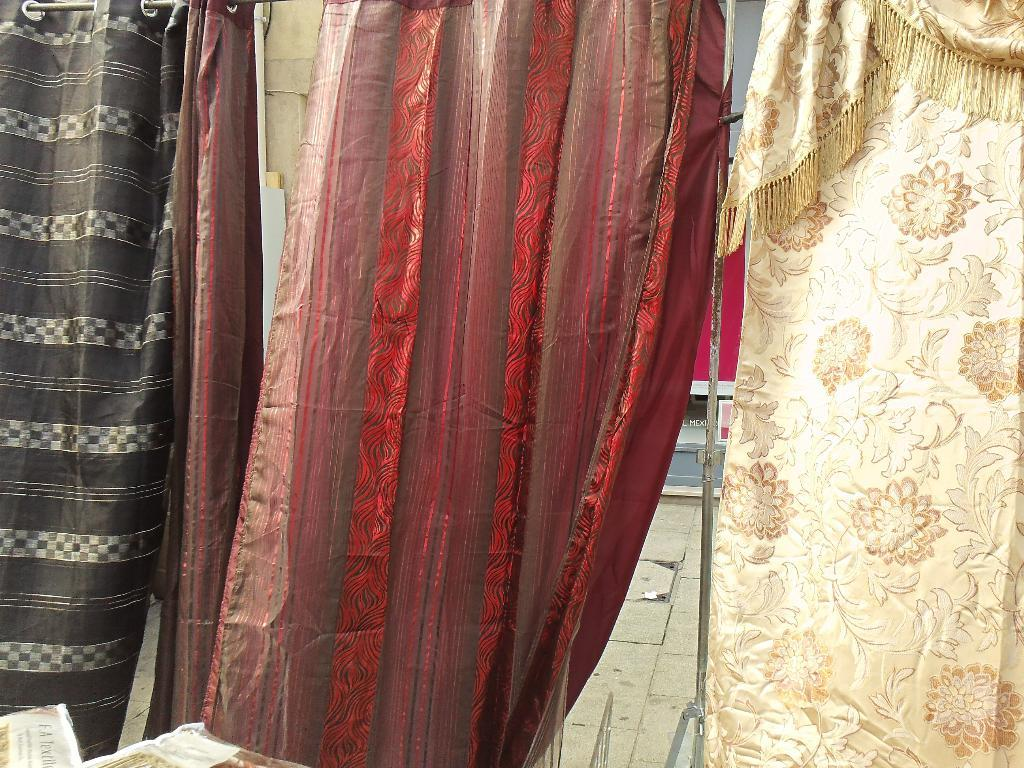What type of window treatment is present in the image? There are curtains in the image. What colors are the curtains? The curtains are in black, red, and cream colors. What can be seen in the background of the image? There is a floor visible in the background of the image. What time of day is it in the image, as indicated by the position of the plant? There is no plant present in the image, so it is not possible to determine the time of day based on its position. 